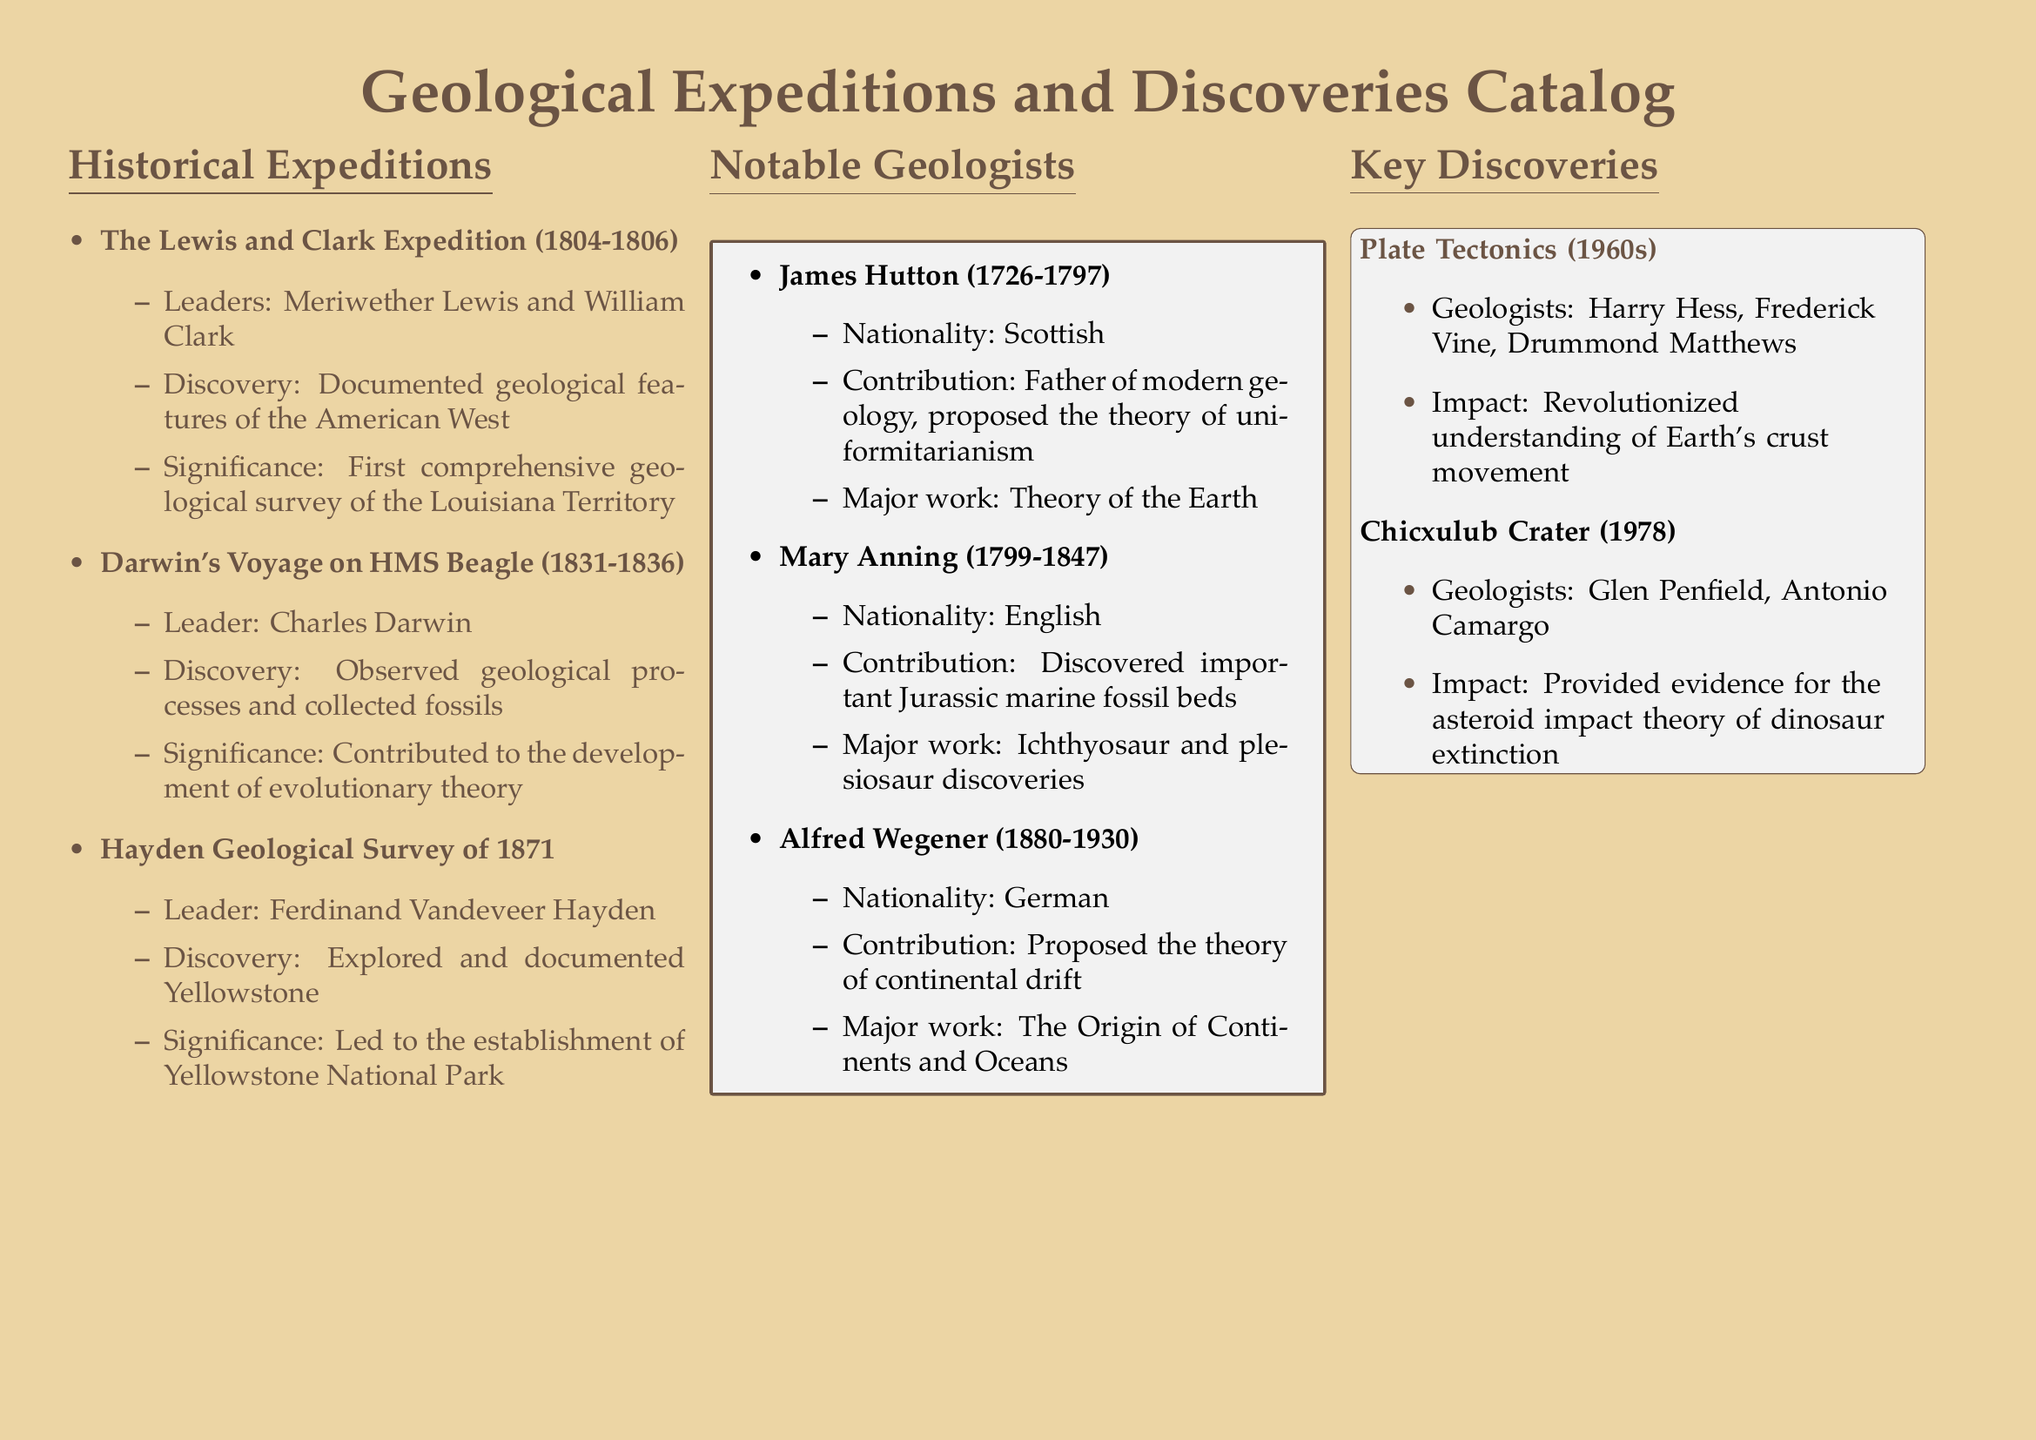What was the year range of the Lewis and Clark Expedition? The year range is explicitly mentioned in the document under the historical expeditions section, which states the expedition took place from 1804 to 1806.
Answer: 1804-1806 Who led Darwin's Voyage on HMS Beagle? The document specifies that Charles Darwin was the leader of the voyage on HMS Beagle, as mentioned in the historical expeditions section.
Answer: Charles Darwin What is the significance of the Hayden Geological Survey of 1871? The significance is provided in the discoveries related to the Hayden Geological Survey, which states it led to the establishment of Yellowstone National Park.
Answer: Established Yellowstone National Park Who is known as the father of modern geology? The document identifies James Hutton as the father of modern geology in the notable geologists section.
Answer: James Hutton What major theory did Alfred Wegener propose? The document notes that Alfred Wegener proposed the theory of continental drift, found in the notable geologists section.
Answer: Theory of continental drift Which geological feature did the Chicxulub Crater relate to? The document mentions that the Chicxulub Crater provided evidence for the asteroid impact theory of dinosaur extinction under the key discoveries section.
Answer: Dinosaur extinction How many geologists are associated with plate tectonics in the document? The document lists three geologists associated with plate tectonics, which is specified in the key discoveries section.
Answer: Three What did Mary Anning discover? The document states that Mary Anning discovered important Jurassic marine fossil beds in the notable geologists section.
Answer: Jurassic marine fossil beds What is the main work of James Hutton cited in the document? The document mentions "Theory of the Earth" as the major work of James Hutton in the notable geologists section.
Answer: Theory of the Earth 